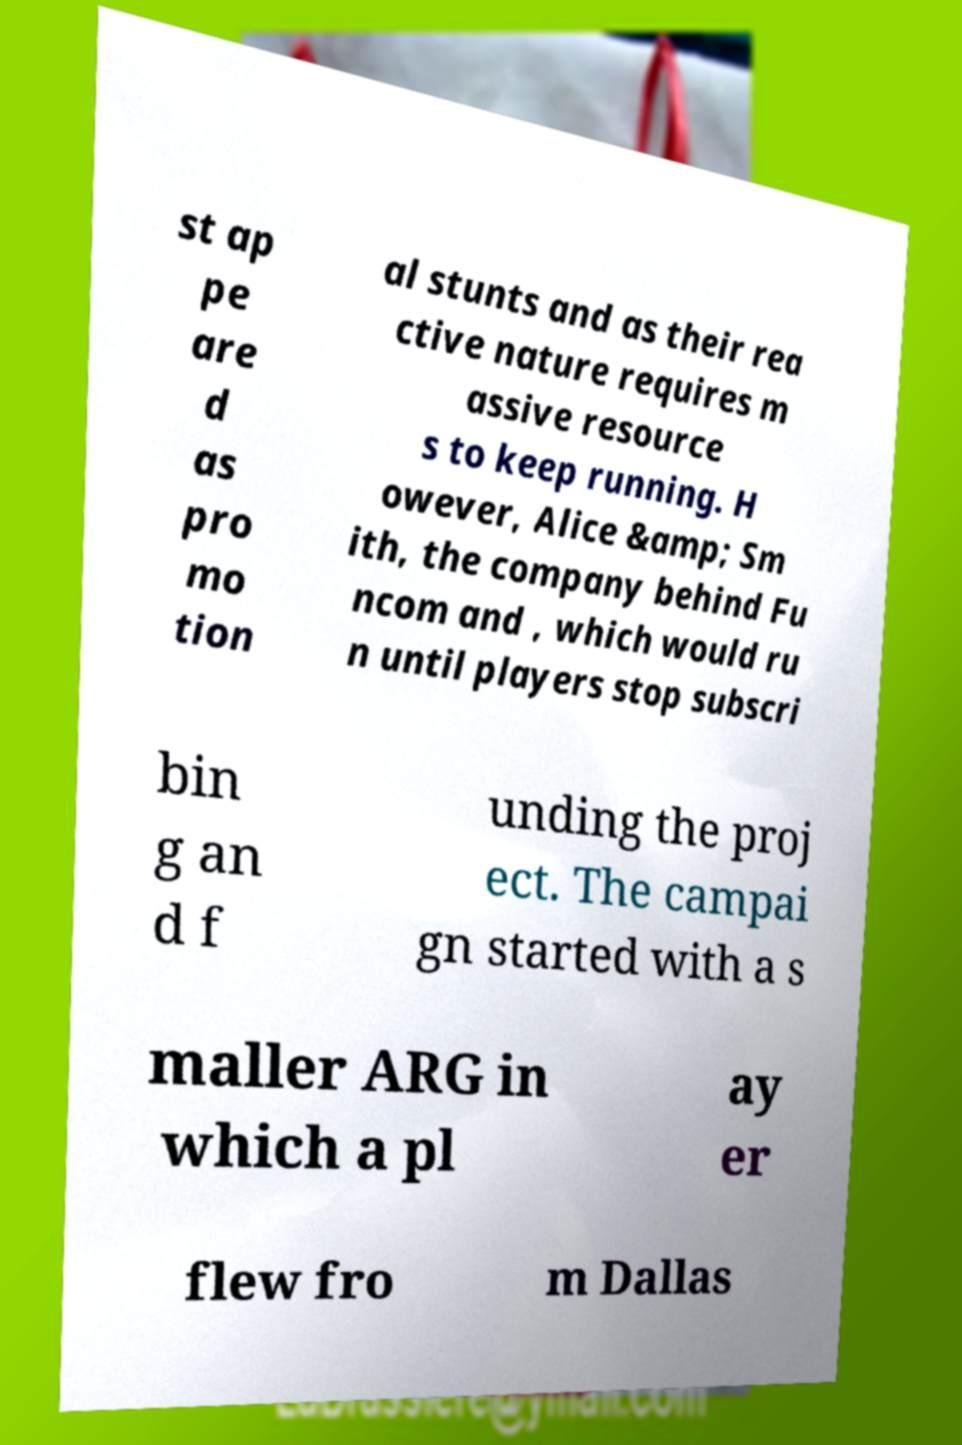Please read and relay the text visible in this image. What does it say? st ap pe are d as pro mo tion al stunts and as their rea ctive nature requires m assive resource s to keep running. H owever, Alice &amp; Sm ith, the company behind Fu ncom and , which would ru n until players stop subscri bin g an d f unding the proj ect. The campai gn started with a s maller ARG in which a pl ay er flew fro m Dallas 